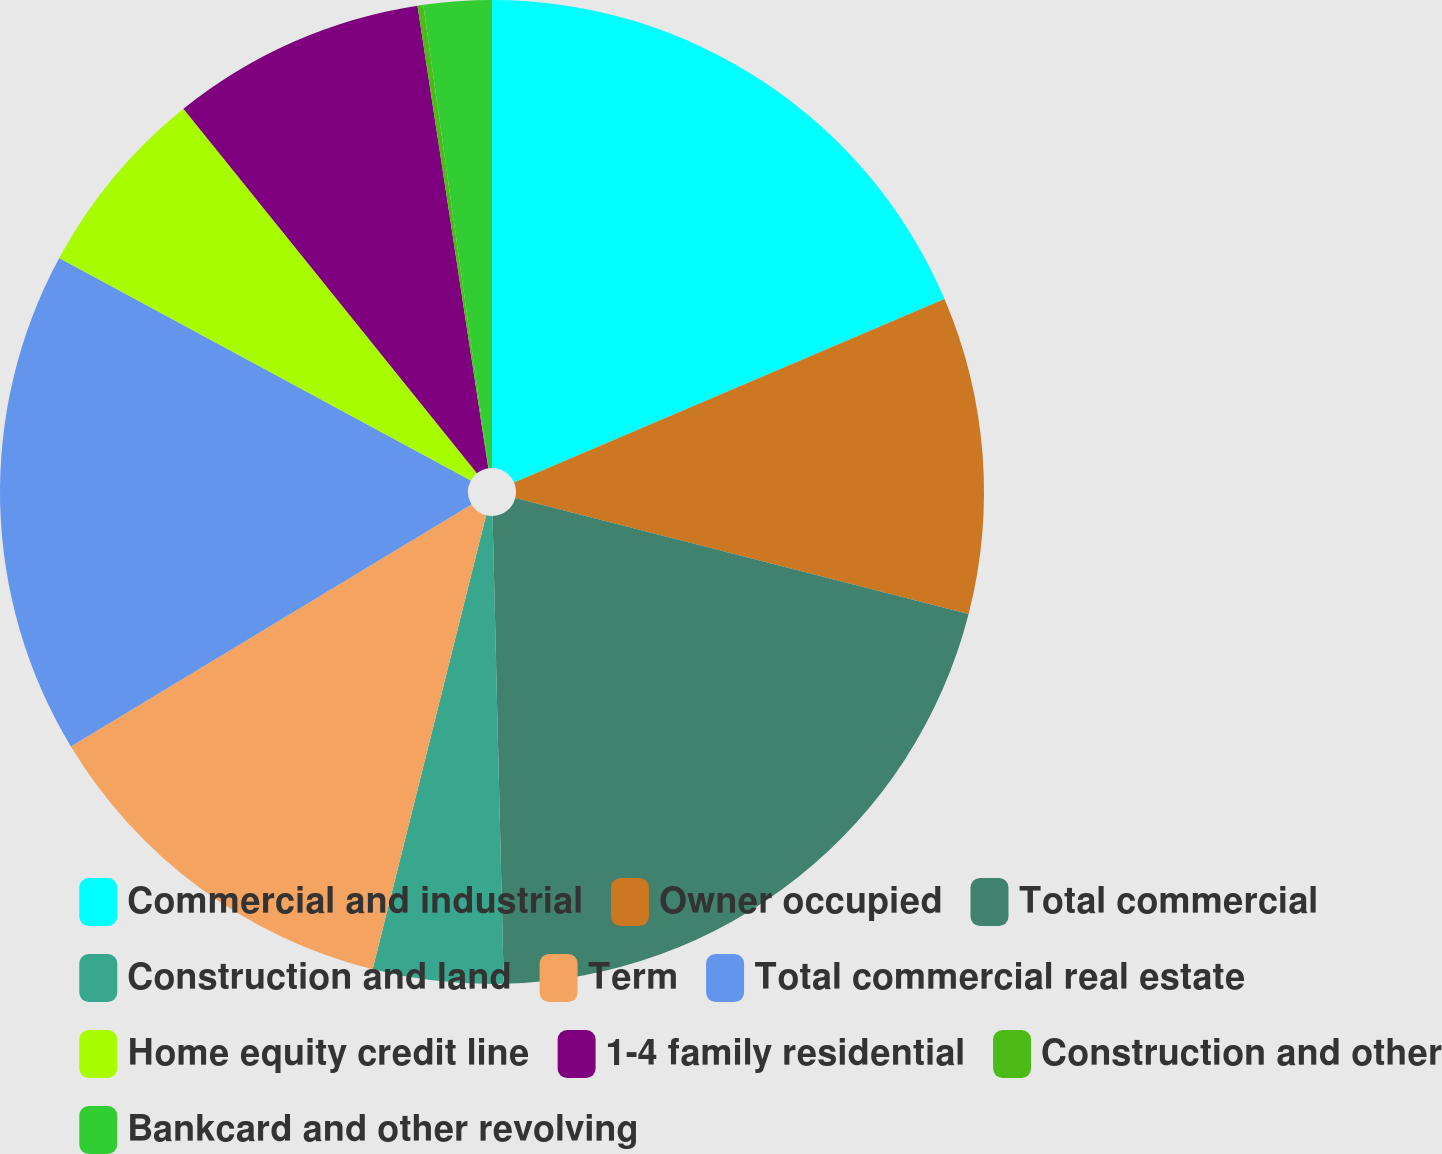<chart> <loc_0><loc_0><loc_500><loc_500><pie_chart><fcel>Commercial and industrial<fcel>Owner occupied<fcel>Total commercial<fcel>Construction and land<fcel>Term<fcel>Total commercial real estate<fcel>Home equity credit line<fcel>1-4 family residential<fcel>Construction and other<fcel>Bankcard and other revolving<nl><fcel>18.58%<fcel>10.41%<fcel>20.63%<fcel>4.28%<fcel>12.45%<fcel>16.54%<fcel>6.32%<fcel>8.37%<fcel>0.19%<fcel>2.23%<nl></chart> 